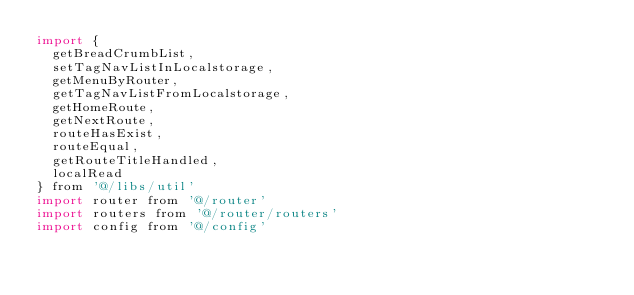<code> <loc_0><loc_0><loc_500><loc_500><_JavaScript_>import {
  getBreadCrumbList,
  setTagNavListInLocalstorage,
  getMenuByRouter,
  getTagNavListFromLocalstorage,
  getHomeRoute,
  getNextRoute,
  routeHasExist,
  routeEqual,
  getRouteTitleHandled,
  localRead
} from '@/libs/util'
import router from '@/router'
import routers from '@/router/routers'
import config from '@/config'
</code> 